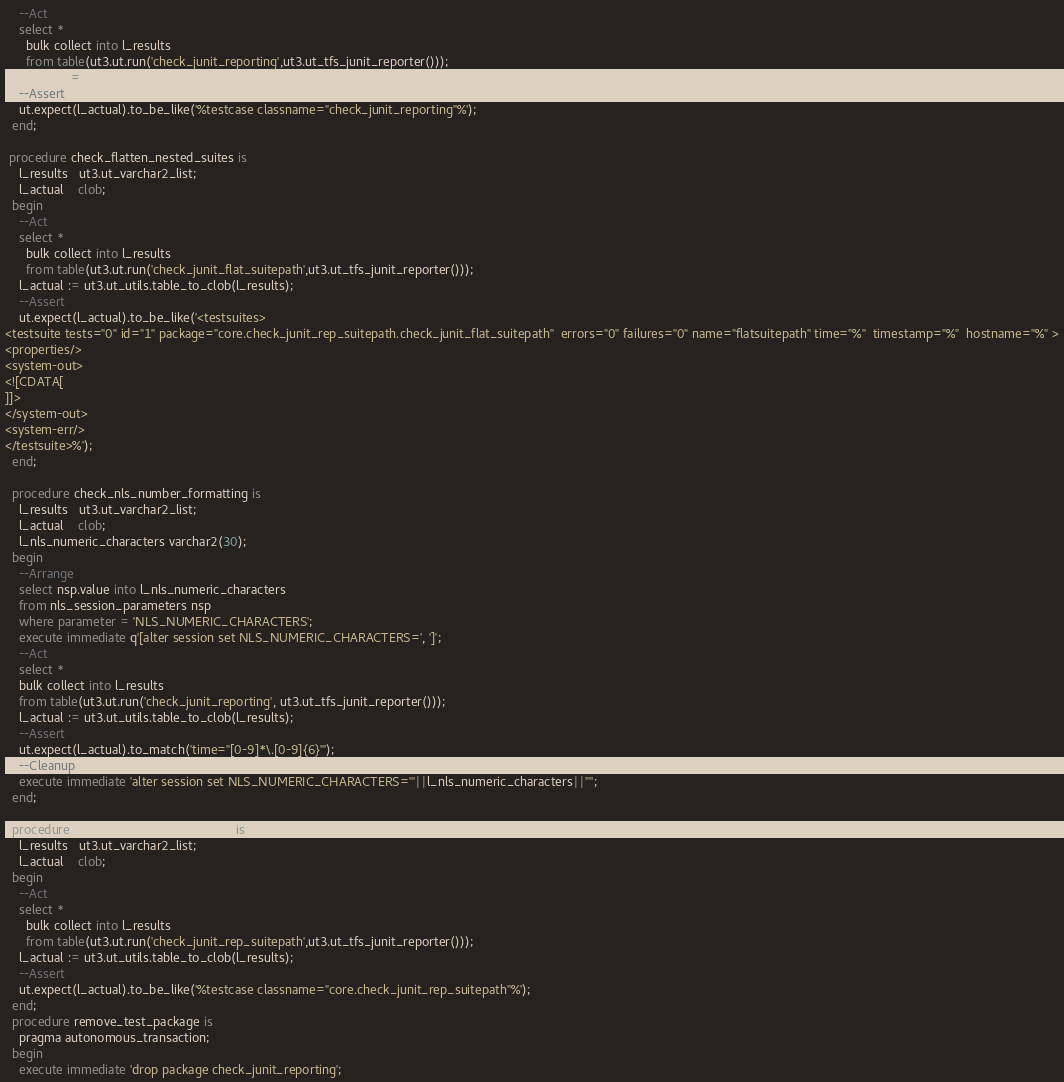<code> <loc_0><loc_0><loc_500><loc_500><_SQL_>    --Act
    select *
      bulk collect into l_results
      from table(ut3.ut.run('check_junit_reporting',ut3.ut_tfs_junit_reporter()));
    l_actual := ut3.ut_utils.table_to_clob(l_results);
    --Assert
    ut.expect(l_actual).to_be_like('%testcase classname="check_junit_reporting"%');
  end;
 
 procedure check_flatten_nested_suites is
    l_results   ut3.ut_varchar2_list;
    l_actual    clob;    
  begin
    --Act
    select *
      bulk collect into l_results
      from table(ut3.ut.run('check_junit_flat_suitepath',ut3.ut_tfs_junit_reporter()));
    l_actual := ut3.ut_utils.table_to_clob(l_results);
    --Assert
    ut.expect(l_actual).to_be_like('<testsuites>
<testsuite tests="0" id="1" package="core.check_junit_rep_suitepath.check_junit_flat_suitepath"  errors="0" failures="0" name="flatsuitepath" time="%"  timestamp="%"  hostname="%" >
<properties/>
<system-out>
<![CDATA[
]]>
</system-out>
<system-err/>
</testsuite>%');
  end;
  
  procedure check_nls_number_formatting is
    l_results   ut3.ut_varchar2_list;
    l_actual    clob;
    l_nls_numeric_characters varchar2(30);
  begin
    --Arrange
    select nsp.value into l_nls_numeric_characters
    from nls_session_parameters nsp
    where parameter = 'NLS_NUMERIC_CHARACTERS';
    execute immediate q'[alter session set NLS_NUMERIC_CHARACTERS=', ']';
    --Act
    select *
    bulk collect into l_results
    from table(ut3.ut.run('check_junit_reporting', ut3.ut_tfs_junit_reporter()));
    l_actual := ut3.ut_utils.table_to_clob(l_results);
    --Assert
    ut.expect(l_actual).to_match('time="[0-9]*\.[0-9]{6}"');
    --Cleanup
    execute immediate 'alter session set NLS_NUMERIC_CHARACTERS='''||l_nls_numeric_characters||'''';
  end;

  procedure check_classname_suitepath is
    l_results   ut3.ut_varchar2_list;
    l_actual    clob;    
  begin
    --Act
    select *
      bulk collect into l_results
      from table(ut3.ut.run('check_junit_rep_suitepath',ut3.ut_tfs_junit_reporter()));
    l_actual := ut3.ut_utils.table_to_clob(l_results);
    --Assert
    ut.expect(l_actual).to_be_like('%testcase classname="core.check_junit_rep_suitepath"%');   
  end;
  procedure remove_test_package is
    pragma autonomous_transaction;
  begin
    execute immediate 'drop package check_junit_reporting';</code> 